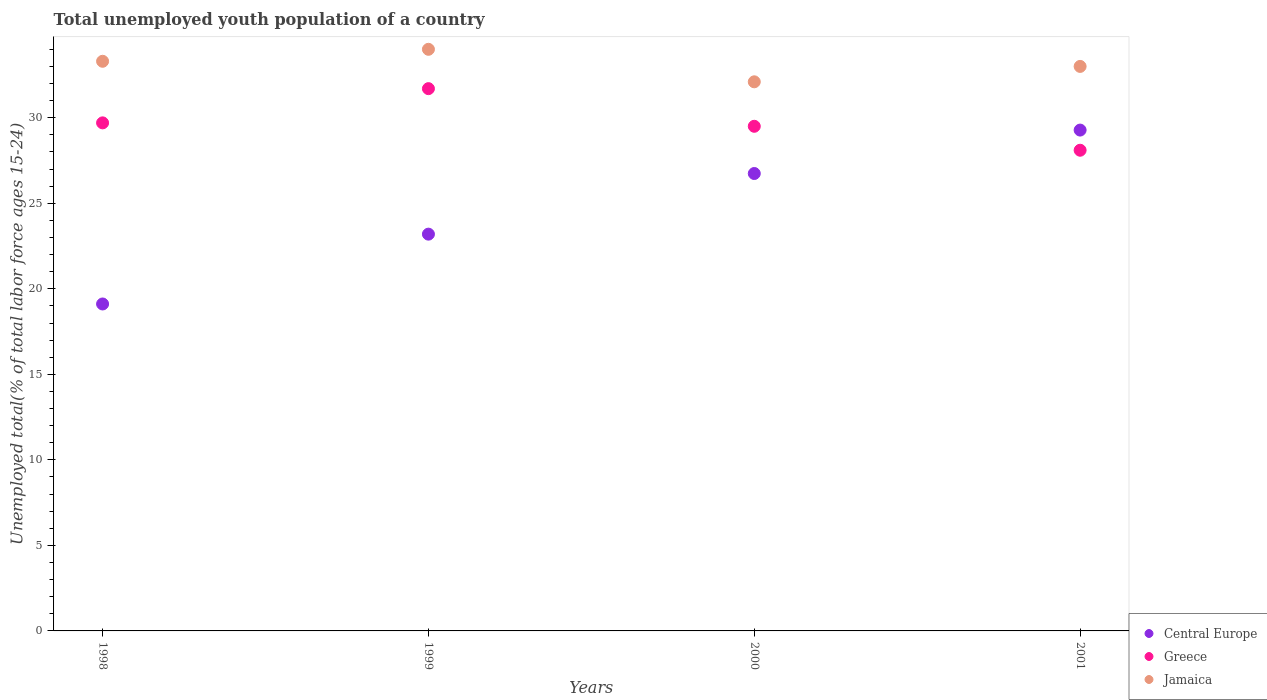How many different coloured dotlines are there?
Your answer should be very brief. 3. Is the number of dotlines equal to the number of legend labels?
Offer a terse response. Yes. What is the percentage of total unemployed youth population of a country in Jamaica in 2001?
Offer a very short reply. 33. Across all years, what is the maximum percentage of total unemployed youth population of a country in Greece?
Provide a succinct answer. 31.7. Across all years, what is the minimum percentage of total unemployed youth population of a country in Central Europe?
Your answer should be very brief. 19.11. In which year was the percentage of total unemployed youth population of a country in Greece maximum?
Ensure brevity in your answer.  1999. What is the total percentage of total unemployed youth population of a country in Central Europe in the graph?
Provide a short and direct response. 98.32. What is the difference between the percentage of total unemployed youth population of a country in Jamaica in 1998 and that in 2000?
Provide a short and direct response. 1.2. What is the difference between the percentage of total unemployed youth population of a country in Central Europe in 1999 and the percentage of total unemployed youth population of a country in Greece in 2001?
Offer a terse response. -4.91. What is the average percentage of total unemployed youth population of a country in Greece per year?
Provide a short and direct response. 29.75. In the year 2000, what is the difference between the percentage of total unemployed youth population of a country in Jamaica and percentage of total unemployed youth population of a country in Central Europe?
Provide a succinct answer. 5.36. What is the ratio of the percentage of total unemployed youth population of a country in Jamaica in 1998 to that in 1999?
Give a very brief answer. 0.98. What is the difference between the highest and the second highest percentage of total unemployed youth population of a country in Jamaica?
Your response must be concise. 0.7. What is the difference between the highest and the lowest percentage of total unemployed youth population of a country in Greece?
Your response must be concise. 3.6. Is the sum of the percentage of total unemployed youth population of a country in Jamaica in 1999 and 2000 greater than the maximum percentage of total unemployed youth population of a country in Central Europe across all years?
Provide a succinct answer. Yes. Does the percentage of total unemployed youth population of a country in Jamaica monotonically increase over the years?
Give a very brief answer. No. Is the percentage of total unemployed youth population of a country in Jamaica strictly greater than the percentage of total unemployed youth population of a country in Central Europe over the years?
Provide a short and direct response. Yes. How many years are there in the graph?
Keep it short and to the point. 4. What is the difference between two consecutive major ticks on the Y-axis?
Provide a succinct answer. 5. Does the graph contain grids?
Offer a terse response. No. What is the title of the graph?
Offer a very short reply. Total unemployed youth population of a country. Does "Spain" appear as one of the legend labels in the graph?
Provide a short and direct response. No. What is the label or title of the Y-axis?
Provide a succinct answer. Unemployed total(% of total labor force ages 15-24). What is the Unemployed total(% of total labor force ages 15-24) in Central Europe in 1998?
Give a very brief answer. 19.11. What is the Unemployed total(% of total labor force ages 15-24) of Greece in 1998?
Ensure brevity in your answer.  29.7. What is the Unemployed total(% of total labor force ages 15-24) of Jamaica in 1998?
Your response must be concise. 33.3. What is the Unemployed total(% of total labor force ages 15-24) in Central Europe in 1999?
Provide a succinct answer. 23.19. What is the Unemployed total(% of total labor force ages 15-24) in Greece in 1999?
Keep it short and to the point. 31.7. What is the Unemployed total(% of total labor force ages 15-24) of Jamaica in 1999?
Give a very brief answer. 34. What is the Unemployed total(% of total labor force ages 15-24) of Central Europe in 2000?
Provide a succinct answer. 26.74. What is the Unemployed total(% of total labor force ages 15-24) in Greece in 2000?
Make the answer very short. 29.5. What is the Unemployed total(% of total labor force ages 15-24) in Jamaica in 2000?
Your response must be concise. 32.1. What is the Unemployed total(% of total labor force ages 15-24) of Central Europe in 2001?
Ensure brevity in your answer.  29.28. What is the Unemployed total(% of total labor force ages 15-24) in Greece in 2001?
Keep it short and to the point. 28.1. What is the Unemployed total(% of total labor force ages 15-24) of Jamaica in 2001?
Your answer should be compact. 33. Across all years, what is the maximum Unemployed total(% of total labor force ages 15-24) of Central Europe?
Ensure brevity in your answer.  29.28. Across all years, what is the maximum Unemployed total(% of total labor force ages 15-24) in Greece?
Give a very brief answer. 31.7. Across all years, what is the maximum Unemployed total(% of total labor force ages 15-24) of Jamaica?
Your answer should be compact. 34. Across all years, what is the minimum Unemployed total(% of total labor force ages 15-24) in Central Europe?
Provide a short and direct response. 19.11. Across all years, what is the minimum Unemployed total(% of total labor force ages 15-24) of Greece?
Give a very brief answer. 28.1. Across all years, what is the minimum Unemployed total(% of total labor force ages 15-24) in Jamaica?
Provide a short and direct response. 32.1. What is the total Unemployed total(% of total labor force ages 15-24) of Central Europe in the graph?
Your answer should be compact. 98.32. What is the total Unemployed total(% of total labor force ages 15-24) of Greece in the graph?
Offer a very short reply. 119. What is the total Unemployed total(% of total labor force ages 15-24) of Jamaica in the graph?
Your answer should be compact. 132.4. What is the difference between the Unemployed total(% of total labor force ages 15-24) in Central Europe in 1998 and that in 1999?
Provide a short and direct response. -4.08. What is the difference between the Unemployed total(% of total labor force ages 15-24) of Central Europe in 1998 and that in 2000?
Keep it short and to the point. -7.63. What is the difference between the Unemployed total(% of total labor force ages 15-24) of Greece in 1998 and that in 2000?
Give a very brief answer. 0.2. What is the difference between the Unemployed total(% of total labor force ages 15-24) in Central Europe in 1998 and that in 2001?
Provide a succinct answer. -10.17. What is the difference between the Unemployed total(% of total labor force ages 15-24) of Greece in 1998 and that in 2001?
Your response must be concise. 1.6. What is the difference between the Unemployed total(% of total labor force ages 15-24) of Central Europe in 1999 and that in 2000?
Ensure brevity in your answer.  -3.54. What is the difference between the Unemployed total(% of total labor force ages 15-24) of Greece in 1999 and that in 2000?
Offer a terse response. 2.2. What is the difference between the Unemployed total(% of total labor force ages 15-24) in Central Europe in 1999 and that in 2001?
Your response must be concise. -6.08. What is the difference between the Unemployed total(% of total labor force ages 15-24) of Greece in 1999 and that in 2001?
Make the answer very short. 3.6. What is the difference between the Unemployed total(% of total labor force ages 15-24) in Jamaica in 1999 and that in 2001?
Your response must be concise. 1. What is the difference between the Unemployed total(% of total labor force ages 15-24) of Central Europe in 2000 and that in 2001?
Provide a short and direct response. -2.54. What is the difference between the Unemployed total(% of total labor force ages 15-24) in Jamaica in 2000 and that in 2001?
Give a very brief answer. -0.9. What is the difference between the Unemployed total(% of total labor force ages 15-24) in Central Europe in 1998 and the Unemployed total(% of total labor force ages 15-24) in Greece in 1999?
Offer a very short reply. -12.59. What is the difference between the Unemployed total(% of total labor force ages 15-24) in Central Europe in 1998 and the Unemployed total(% of total labor force ages 15-24) in Jamaica in 1999?
Provide a short and direct response. -14.89. What is the difference between the Unemployed total(% of total labor force ages 15-24) in Greece in 1998 and the Unemployed total(% of total labor force ages 15-24) in Jamaica in 1999?
Your answer should be compact. -4.3. What is the difference between the Unemployed total(% of total labor force ages 15-24) in Central Europe in 1998 and the Unemployed total(% of total labor force ages 15-24) in Greece in 2000?
Keep it short and to the point. -10.39. What is the difference between the Unemployed total(% of total labor force ages 15-24) of Central Europe in 1998 and the Unemployed total(% of total labor force ages 15-24) of Jamaica in 2000?
Keep it short and to the point. -12.99. What is the difference between the Unemployed total(% of total labor force ages 15-24) in Greece in 1998 and the Unemployed total(% of total labor force ages 15-24) in Jamaica in 2000?
Give a very brief answer. -2.4. What is the difference between the Unemployed total(% of total labor force ages 15-24) of Central Europe in 1998 and the Unemployed total(% of total labor force ages 15-24) of Greece in 2001?
Your answer should be very brief. -8.99. What is the difference between the Unemployed total(% of total labor force ages 15-24) in Central Europe in 1998 and the Unemployed total(% of total labor force ages 15-24) in Jamaica in 2001?
Make the answer very short. -13.89. What is the difference between the Unemployed total(% of total labor force ages 15-24) in Central Europe in 1999 and the Unemployed total(% of total labor force ages 15-24) in Greece in 2000?
Offer a very short reply. -6.31. What is the difference between the Unemployed total(% of total labor force ages 15-24) of Central Europe in 1999 and the Unemployed total(% of total labor force ages 15-24) of Jamaica in 2000?
Provide a short and direct response. -8.91. What is the difference between the Unemployed total(% of total labor force ages 15-24) in Greece in 1999 and the Unemployed total(% of total labor force ages 15-24) in Jamaica in 2000?
Keep it short and to the point. -0.4. What is the difference between the Unemployed total(% of total labor force ages 15-24) of Central Europe in 1999 and the Unemployed total(% of total labor force ages 15-24) of Greece in 2001?
Give a very brief answer. -4.91. What is the difference between the Unemployed total(% of total labor force ages 15-24) in Central Europe in 1999 and the Unemployed total(% of total labor force ages 15-24) in Jamaica in 2001?
Offer a terse response. -9.81. What is the difference between the Unemployed total(% of total labor force ages 15-24) of Central Europe in 2000 and the Unemployed total(% of total labor force ages 15-24) of Greece in 2001?
Provide a short and direct response. -1.36. What is the difference between the Unemployed total(% of total labor force ages 15-24) in Central Europe in 2000 and the Unemployed total(% of total labor force ages 15-24) in Jamaica in 2001?
Provide a succinct answer. -6.26. What is the difference between the Unemployed total(% of total labor force ages 15-24) in Greece in 2000 and the Unemployed total(% of total labor force ages 15-24) in Jamaica in 2001?
Give a very brief answer. -3.5. What is the average Unemployed total(% of total labor force ages 15-24) in Central Europe per year?
Your answer should be very brief. 24.58. What is the average Unemployed total(% of total labor force ages 15-24) of Greece per year?
Your answer should be compact. 29.75. What is the average Unemployed total(% of total labor force ages 15-24) of Jamaica per year?
Your answer should be compact. 33.1. In the year 1998, what is the difference between the Unemployed total(% of total labor force ages 15-24) in Central Europe and Unemployed total(% of total labor force ages 15-24) in Greece?
Your answer should be compact. -10.59. In the year 1998, what is the difference between the Unemployed total(% of total labor force ages 15-24) in Central Europe and Unemployed total(% of total labor force ages 15-24) in Jamaica?
Your answer should be compact. -14.19. In the year 1998, what is the difference between the Unemployed total(% of total labor force ages 15-24) in Greece and Unemployed total(% of total labor force ages 15-24) in Jamaica?
Offer a very short reply. -3.6. In the year 1999, what is the difference between the Unemployed total(% of total labor force ages 15-24) of Central Europe and Unemployed total(% of total labor force ages 15-24) of Greece?
Offer a very short reply. -8.51. In the year 1999, what is the difference between the Unemployed total(% of total labor force ages 15-24) of Central Europe and Unemployed total(% of total labor force ages 15-24) of Jamaica?
Keep it short and to the point. -10.81. In the year 1999, what is the difference between the Unemployed total(% of total labor force ages 15-24) of Greece and Unemployed total(% of total labor force ages 15-24) of Jamaica?
Provide a short and direct response. -2.3. In the year 2000, what is the difference between the Unemployed total(% of total labor force ages 15-24) in Central Europe and Unemployed total(% of total labor force ages 15-24) in Greece?
Offer a very short reply. -2.76. In the year 2000, what is the difference between the Unemployed total(% of total labor force ages 15-24) of Central Europe and Unemployed total(% of total labor force ages 15-24) of Jamaica?
Provide a short and direct response. -5.36. In the year 2001, what is the difference between the Unemployed total(% of total labor force ages 15-24) in Central Europe and Unemployed total(% of total labor force ages 15-24) in Greece?
Offer a terse response. 1.18. In the year 2001, what is the difference between the Unemployed total(% of total labor force ages 15-24) of Central Europe and Unemployed total(% of total labor force ages 15-24) of Jamaica?
Your answer should be compact. -3.72. In the year 2001, what is the difference between the Unemployed total(% of total labor force ages 15-24) in Greece and Unemployed total(% of total labor force ages 15-24) in Jamaica?
Keep it short and to the point. -4.9. What is the ratio of the Unemployed total(% of total labor force ages 15-24) in Central Europe in 1998 to that in 1999?
Make the answer very short. 0.82. What is the ratio of the Unemployed total(% of total labor force ages 15-24) of Greece in 1998 to that in 1999?
Provide a succinct answer. 0.94. What is the ratio of the Unemployed total(% of total labor force ages 15-24) in Jamaica in 1998 to that in 1999?
Offer a terse response. 0.98. What is the ratio of the Unemployed total(% of total labor force ages 15-24) in Central Europe in 1998 to that in 2000?
Provide a succinct answer. 0.71. What is the ratio of the Unemployed total(% of total labor force ages 15-24) of Greece in 1998 to that in 2000?
Make the answer very short. 1.01. What is the ratio of the Unemployed total(% of total labor force ages 15-24) of Jamaica in 1998 to that in 2000?
Your response must be concise. 1.04. What is the ratio of the Unemployed total(% of total labor force ages 15-24) in Central Europe in 1998 to that in 2001?
Your answer should be compact. 0.65. What is the ratio of the Unemployed total(% of total labor force ages 15-24) of Greece in 1998 to that in 2001?
Offer a very short reply. 1.06. What is the ratio of the Unemployed total(% of total labor force ages 15-24) of Jamaica in 1998 to that in 2001?
Ensure brevity in your answer.  1.01. What is the ratio of the Unemployed total(% of total labor force ages 15-24) of Central Europe in 1999 to that in 2000?
Your answer should be very brief. 0.87. What is the ratio of the Unemployed total(% of total labor force ages 15-24) in Greece in 1999 to that in 2000?
Give a very brief answer. 1.07. What is the ratio of the Unemployed total(% of total labor force ages 15-24) of Jamaica in 1999 to that in 2000?
Your response must be concise. 1.06. What is the ratio of the Unemployed total(% of total labor force ages 15-24) of Central Europe in 1999 to that in 2001?
Ensure brevity in your answer.  0.79. What is the ratio of the Unemployed total(% of total labor force ages 15-24) of Greece in 1999 to that in 2001?
Your answer should be compact. 1.13. What is the ratio of the Unemployed total(% of total labor force ages 15-24) in Jamaica in 1999 to that in 2001?
Your response must be concise. 1.03. What is the ratio of the Unemployed total(% of total labor force ages 15-24) in Central Europe in 2000 to that in 2001?
Ensure brevity in your answer.  0.91. What is the ratio of the Unemployed total(% of total labor force ages 15-24) of Greece in 2000 to that in 2001?
Provide a short and direct response. 1.05. What is the ratio of the Unemployed total(% of total labor force ages 15-24) of Jamaica in 2000 to that in 2001?
Offer a terse response. 0.97. What is the difference between the highest and the second highest Unemployed total(% of total labor force ages 15-24) of Central Europe?
Ensure brevity in your answer.  2.54. What is the difference between the highest and the lowest Unemployed total(% of total labor force ages 15-24) in Central Europe?
Your answer should be compact. 10.17. What is the difference between the highest and the lowest Unemployed total(% of total labor force ages 15-24) in Greece?
Ensure brevity in your answer.  3.6. What is the difference between the highest and the lowest Unemployed total(% of total labor force ages 15-24) in Jamaica?
Keep it short and to the point. 1.9. 